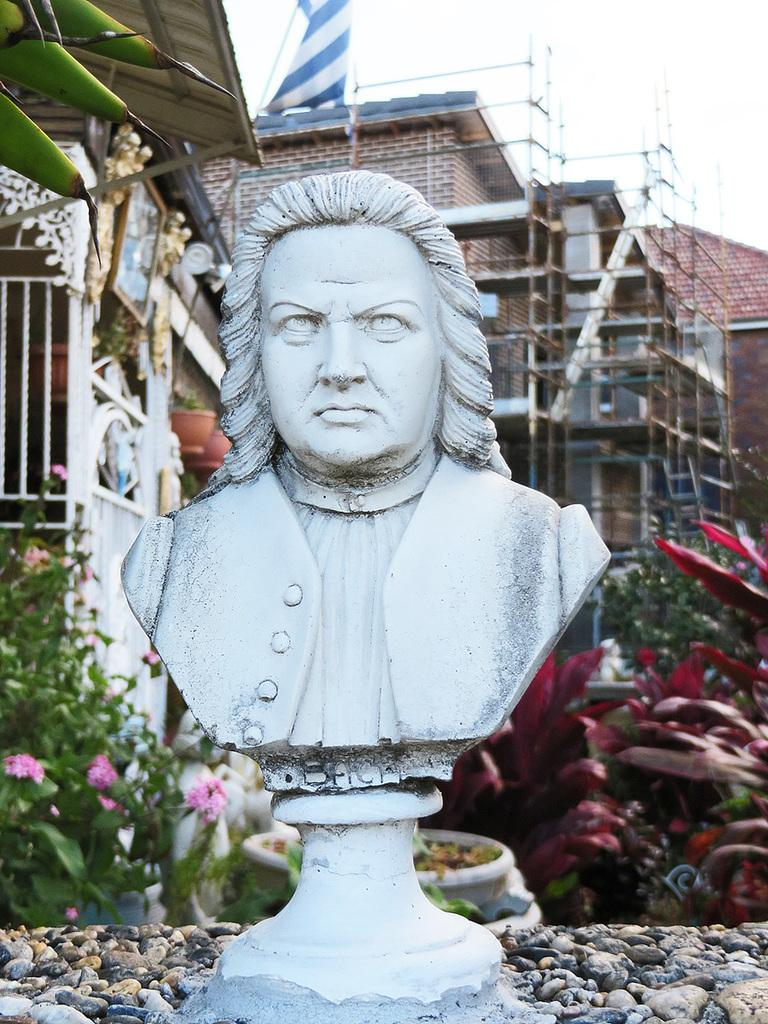What is the main subject of the image? There is a sculpture of a person in the image. What type of material can be seen in the image? Stones are visible in the image. What type of natural elements are present in the image? There are plants in the image. What type of man-made structures can be seen in the image? There are buildings in the image. What type of barrier is present in the image? There is a fence in the image. What is visible in the background of the image? The sky is visible in the image. What type of plate is being used to destroy the sculpture in the image? There is no plate or destruction present in the image; it features a sculpture of a person with various other elements. 